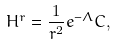Convert formula to latex. <formula><loc_0><loc_0><loc_500><loc_500>H ^ { r } = \frac { 1 } { r ^ { 2 } } e ^ { - \Lambda } C ,</formula> 